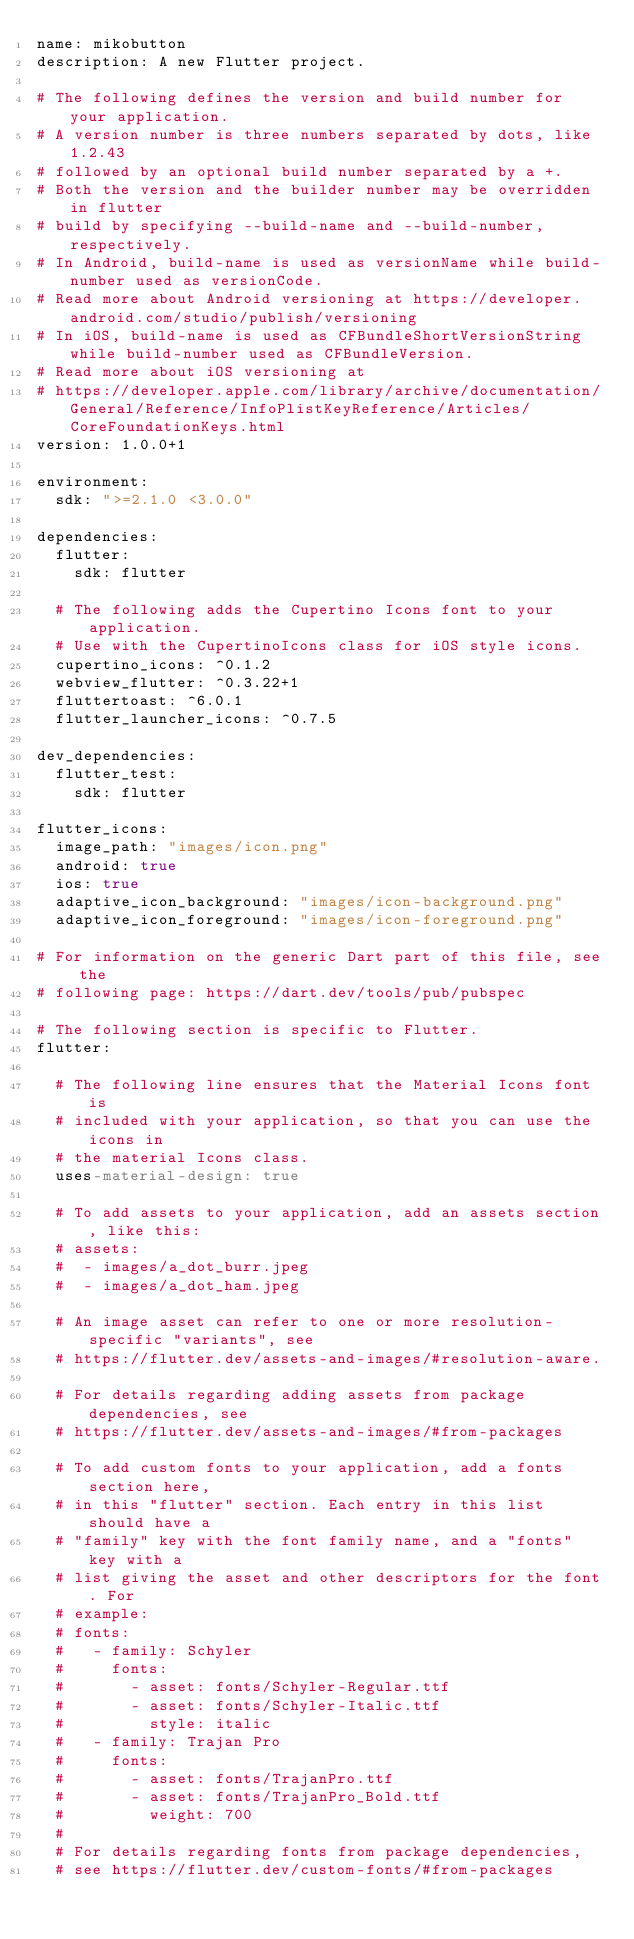<code> <loc_0><loc_0><loc_500><loc_500><_YAML_>name: mikobutton
description: A new Flutter project.

# The following defines the version and build number for your application.
# A version number is three numbers separated by dots, like 1.2.43
# followed by an optional build number separated by a +.
# Both the version and the builder number may be overridden in flutter
# build by specifying --build-name and --build-number, respectively.
# In Android, build-name is used as versionName while build-number used as versionCode.
# Read more about Android versioning at https://developer.android.com/studio/publish/versioning
# In iOS, build-name is used as CFBundleShortVersionString while build-number used as CFBundleVersion.
# Read more about iOS versioning at
# https://developer.apple.com/library/archive/documentation/General/Reference/InfoPlistKeyReference/Articles/CoreFoundationKeys.html
version: 1.0.0+1

environment:
  sdk: ">=2.1.0 <3.0.0"

dependencies:
  flutter:
    sdk: flutter

  # The following adds the Cupertino Icons font to your application.
  # Use with the CupertinoIcons class for iOS style icons.
  cupertino_icons: ^0.1.2
  webview_flutter: ^0.3.22+1
  fluttertoast: ^6.0.1
  flutter_launcher_icons: ^0.7.5

dev_dependencies:
  flutter_test:
    sdk: flutter

flutter_icons:
  image_path: "images/icon.png"
  android: true
  ios: true
  adaptive_icon_background: "images/icon-background.png"
  adaptive_icon_foreground: "images/icon-foreground.png"

# For information on the generic Dart part of this file, see the
# following page: https://dart.dev/tools/pub/pubspec

# The following section is specific to Flutter.
flutter:

  # The following line ensures that the Material Icons font is
  # included with your application, so that you can use the icons in
  # the material Icons class.
  uses-material-design: true

  # To add assets to your application, add an assets section, like this:
  # assets:
  #  - images/a_dot_burr.jpeg
  #  - images/a_dot_ham.jpeg

  # An image asset can refer to one or more resolution-specific "variants", see
  # https://flutter.dev/assets-and-images/#resolution-aware.

  # For details regarding adding assets from package dependencies, see
  # https://flutter.dev/assets-and-images/#from-packages

  # To add custom fonts to your application, add a fonts section here,
  # in this "flutter" section. Each entry in this list should have a
  # "family" key with the font family name, and a "fonts" key with a
  # list giving the asset and other descriptors for the font. For
  # example:
  # fonts:
  #   - family: Schyler
  #     fonts:
  #       - asset: fonts/Schyler-Regular.ttf
  #       - asset: fonts/Schyler-Italic.ttf
  #         style: italic
  #   - family: Trajan Pro
  #     fonts:
  #       - asset: fonts/TrajanPro.ttf
  #       - asset: fonts/TrajanPro_Bold.ttf
  #         weight: 700
  #
  # For details regarding fonts from package dependencies,
  # see https://flutter.dev/custom-fonts/#from-packages
</code> 